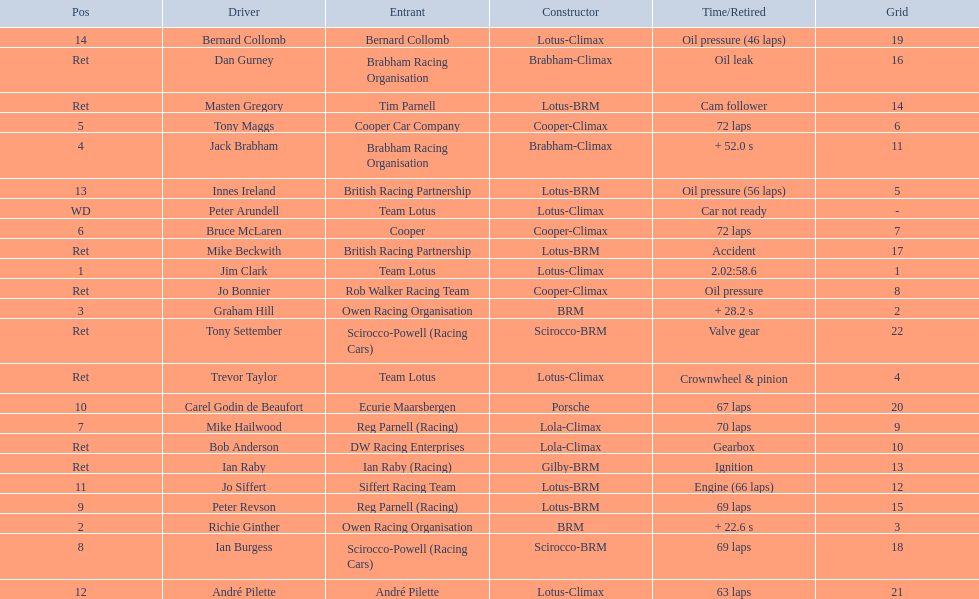Who drove in the 1963 international gold cup? Jim Clark, Richie Ginther, Graham Hill, Jack Brabham, Tony Maggs, Bruce McLaren, Mike Hailwood, Ian Burgess, Peter Revson, Carel Godin de Beaufort, Jo Siffert, André Pilette, Innes Ireland, Bernard Collomb, Ian Raby, Dan Gurney, Mike Beckwith, Masten Gregory, Trevor Taylor, Jo Bonnier, Tony Settember, Bob Anderson, Peter Arundell. Who had problems during the race? Jo Siffert, Innes Ireland, Bernard Collomb, Ian Raby, Dan Gurney, Mike Beckwith, Masten Gregory, Trevor Taylor, Jo Bonnier, Tony Settember, Bob Anderson, Peter Arundell. Of those who was still able to finish the race? Jo Siffert, Innes Ireland, Bernard Collomb. Of those who faced the same issue? Innes Ireland, Bernard Collomb. What issue did they have? Oil pressure. 